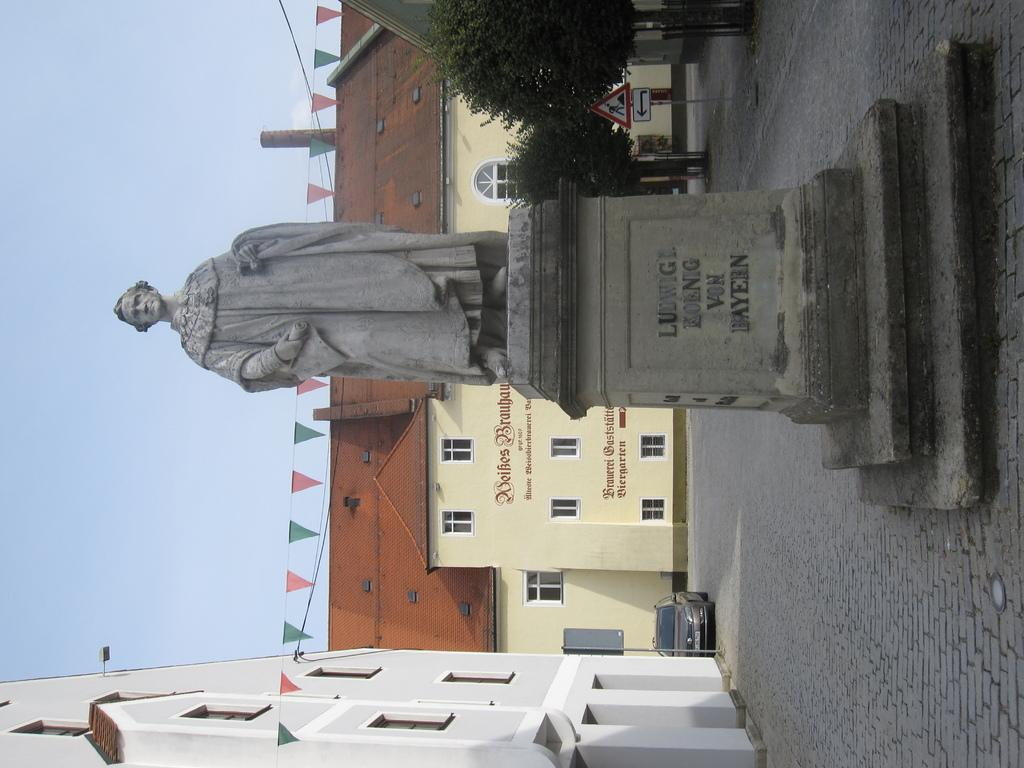Provide a one-sentence caption for the provided image. a man named Ludwig has a statue standing of him. 